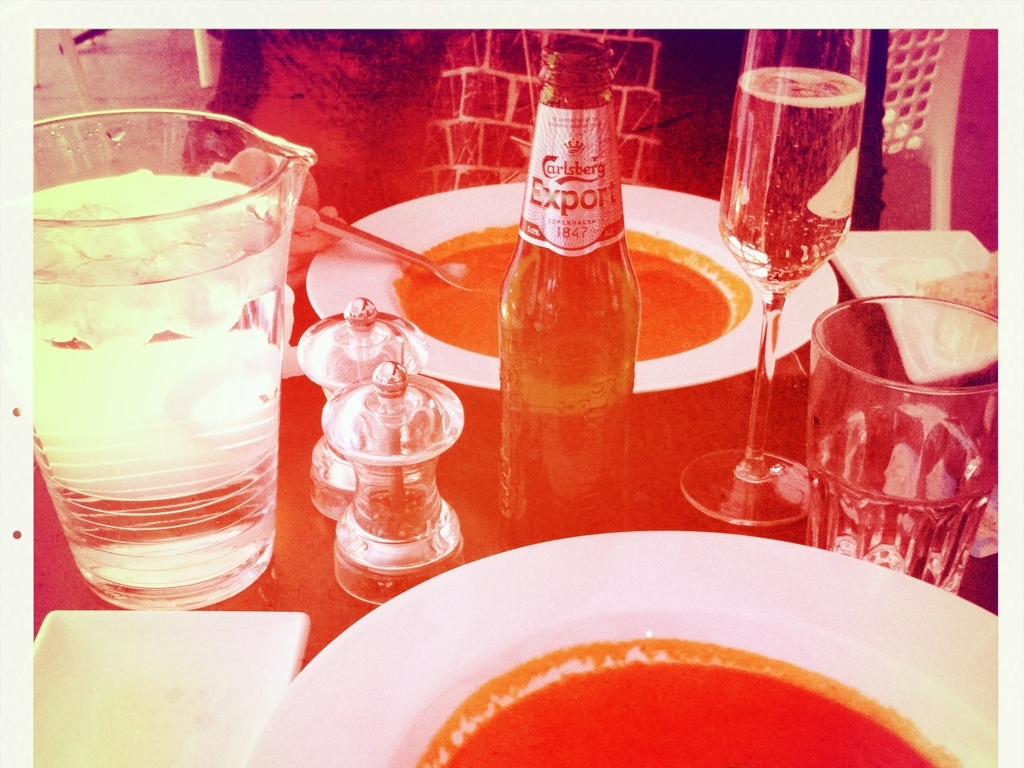Can you describe the items on the table? The image shows a dining table with a few items: there's a bowl of soup, a glass of water with ice, a salt shaker, a beer bottle labeled 'Carlsberg Export,' and a partially visible glass of what seems to be champagne. The table setting suggests that it's a meal for one, with the presence of bread indicating perhaps a starter course. 